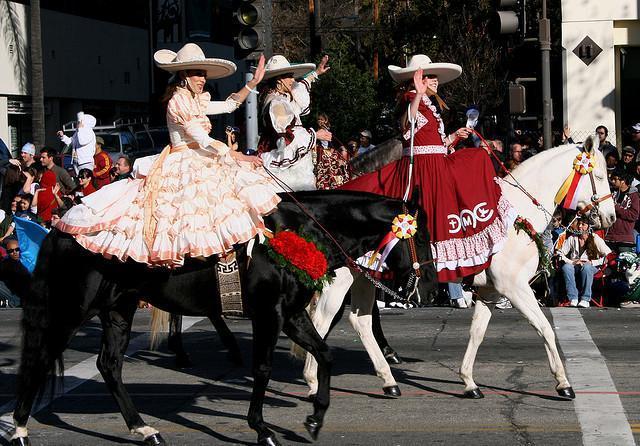How many people are in the photo?
Give a very brief answer. 6. How many horses are in the photo?
Give a very brief answer. 3. How many cows are to the left of the person in the middle?
Give a very brief answer. 0. 